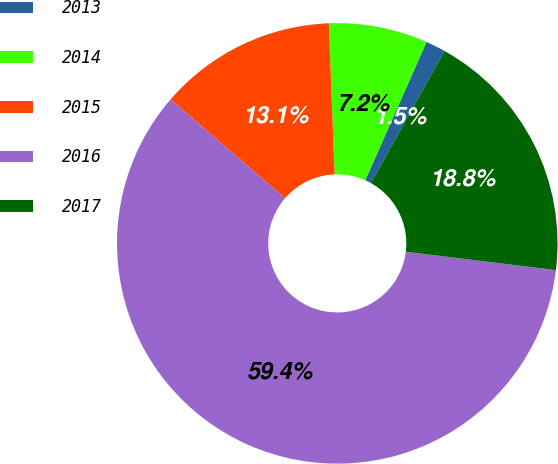<chart> <loc_0><loc_0><loc_500><loc_500><pie_chart><fcel>2013<fcel>2014<fcel>2015<fcel>2016<fcel>2017<nl><fcel>1.46%<fcel>7.25%<fcel>13.05%<fcel>59.4%<fcel>18.84%<nl></chart> 